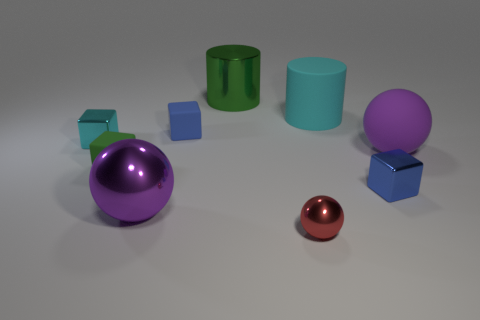Subtract all small blue metallic cubes. How many cubes are left? 3 Subtract all red spheres. How many spheres are left? 2 Subtract all cylinders. How many objects are left? 7 Subtract 1 spheres. How many spheres are left? 2 Subtract all green blocks. Subtract all brown balls. How many blocks are left? 3 Add 7 balls. How many balls exist? 10 Subtract 1 green cubes. How many objects are left? 8 Subtract all yellow balls. How many green cubes are left? 1 Subtract all metal things. Subtract all small shiny cubes. How many objects are left? 2 Add 1 purple balls. How many purple balls are left? 3 